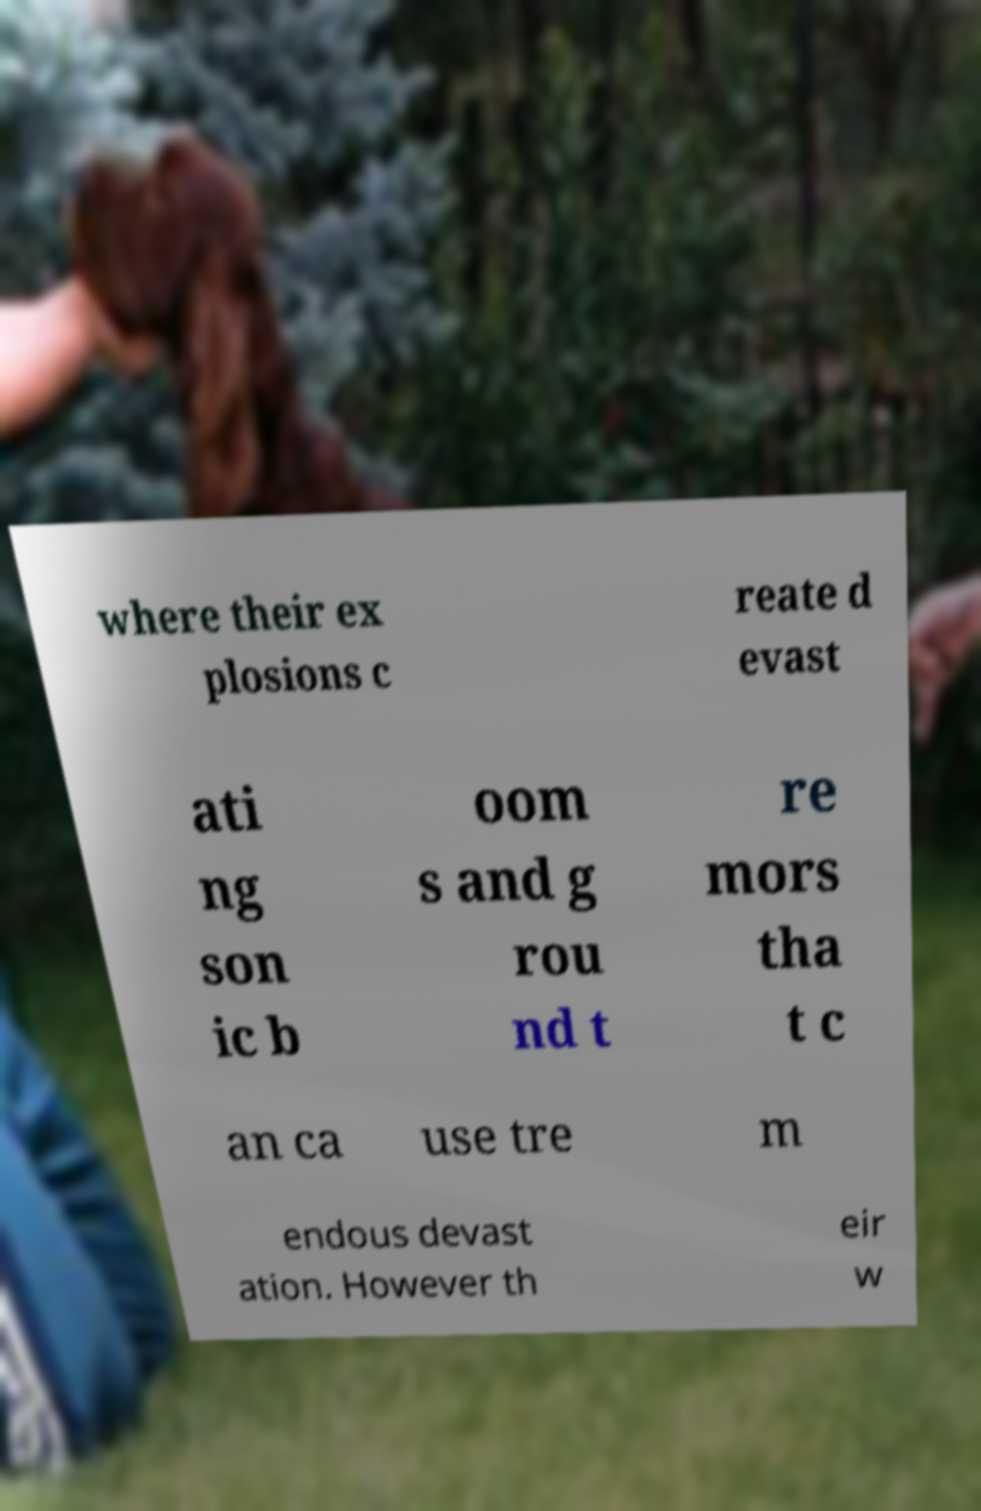Please identify and transcribe the text found in this image. where their ex plosions c reate d evast ati ng son ic b oom s and g rou nd t re mors tha t c an ca use tre m endous devast ation. However th eir w 